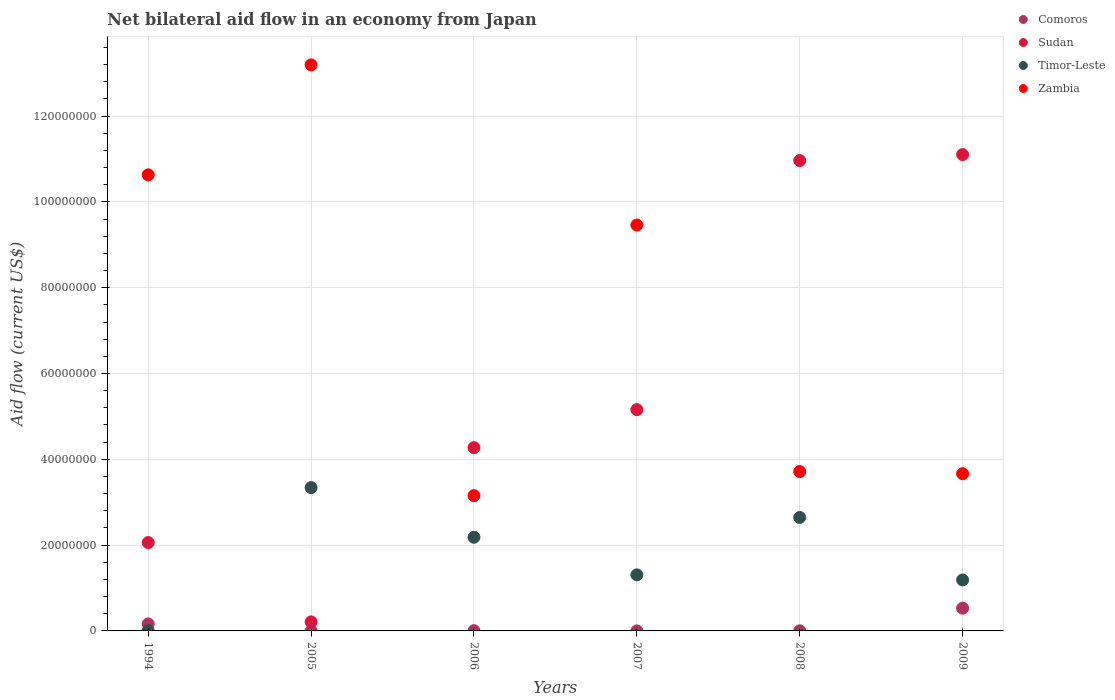How many different coloured dotlines are there?
Provide a short and direct response. 4. What is the net bilateral aid flow in Zambia in 1994?
Offer a terse response. 1.06e+08. Across all years, what is the maximum net bilateral aid flow in Sudan?
Your answer should be very brief. 1.11e+08. Across all years, what is the minimum net bilateral aid flow in Timor-Leste?
Your response must be concise. 7.00e+04. What is the total net bilateral aid flow in Timor-Leste in the graph?
Your answer should be compact. 1.07e+08. What is the difference between the net bilateral aid flow in Zambia in 1994 and that in 2009?
Ensure brevity in your answer.  6.97e+07. What is the difference between the net bilateral aid flow in Zambia in 1994 and the net bilateral aid flow in Comoros in 2005?
Give a very brief answer. 1.06e+08. What is the average net bilateral aid flow in Comoros per year?
Offer a terse response. 1.18e+06. In the year 1994, what is the difference between the net bilateral aid flow in Timor-Leste and net bilateral aid flow in Sudan?
Provide a succinct answer. -2.05e+07. What is the ratio of the net bilateral aid flow in Sudan in 1994 to that in 2006?
Your response must be concise. 0.48. Is the difference between the net bilateral aid flow in Timor-Leste in 2008 and 2009 greater than the difference between the net bilateral aid flow in Sudan in 2008 and 2009?
Your response must be concise. Yes. What is the difference between the highest and the second highest net bilateral aid flow in Zambia?
Give a very brief answer. 2.56e+07. What is the difference between the highest and the lowest net bilateral aid flow in Comoros?
Your answer should be compact. 5.29e+06. In how many years, is the net bilateral aid flow in Comoros greater than the average net bilateral aid flow in Comoros taken over all years?
Offer a very short reply. 2. Is it the case that in every year, the sum of the net bilateral aid flow in Zambia and net bilateral aid flow in Comoros  is greater than the sum of net bilateral aid flow in Sudan and net bilateral aid flow in Timor-Leste?
Make the answer very short. No. Is it the case that in every year, the sum of the net bilateral aid flow in Timor-Leste and net bilateral aid flow in Sudan  is greater than the net bilateral aid flow in Zambia?
Provide a short and direct response. No. Is the net bilateral aid flow in Comoros strictly greater than the net bilateral aid flow in Timor-Leste over the years?
Provide a short and direct response. No. Is the net bilateral aid flow in Timor-Leste strictly less than the net bilateral aid flow in Sudan over the years?
Offer a very short reply. No. How many dotlines are there?
Ensure brevity in your answer.  4. How many years are there in the graph?
Ensure brevity in your answer.  6. What is the difference between two consecutive major ticks on the Y-axis?
Make the answer very short. 2.00e+07. How many legend labels are there?
Your response must be concise. 4. How are the legend labels stacked?
Offer a terse response. Vertical. What is the title of the graph?
Offer a very short reply. Net bilateral aid flow in an economy from Japan. Does "Vietnam" appear as one of the legend labels in the graph?
Keep it short and to the point. No. What is the label or title of the Y-axis?
Provide a short and direct response. Aid flow (current US$). What is the Aid flow (current US$) of Comoros in 1994?
Provide a short and direct response. 1.64e+06. What is the Aid flow (current US$) in Sudan in 1994?
Ensure brevity in your answer.  2.06e+07. What is the Aid flow (current US$) in Timor-Leste in 1994?
Give a very brief answer. 7.00e+04. What is the Aid flow (current US$) in Zambia in 1994?
Provide a short and direct response. 1.06e+08. What is the Aid flow (current US$) in Sudan in 2005?
Offer a terse response. 2.11e+06. What is the Aid flow (current US$) in Timor-Leste in 2005?
Offer a terse response. 3.34e+07. What is the Aid flow (current US$) in Zambia in 2005?
Provide a short and direct response. 1.32e+08. What is the Aid flow (current US$) of Comoros in 2006?
Provide a succinct answer. 6.00e+04. What is the Aid flow (current US$) of Sudan in 2006?
Keep it short and to the point. 4.27e+07. What is the Aid flow (current US$) in Timor-Leste in 2006?
Keep it short and to the point. 2.18e+07. What is the Aid flow (current US$) of Zambia in 2006?
Your answer should be very brief. 3.15e+07. What is the Aid flow (current US$) in Sudan in 2007?
Provide a succinct answer. 5.16e+07. What is the Aid flow (current US$) of Timor-Leste in 2007?
Make the answer very short. 1.31e+07. What is the Aid flow (current US$) in Zambia in 2007?
Your answer should be very brief. 9.46e+07. What is the Aid flow (current US$) in Sudan in 2008?
Ensure brevity in your answer.  1.10e+08. What is the Aid flow (current US$) in Timor-Leste in 2008?
Your response must be concise. 2.64e+07. What is the Aid flow (current US$) of Zambia in 2008?
Your answer should be very brief. 3.71e+07. What is the Aid flow (current US$) of Comoros in 2009?
Your answer should be very brief. 5.30e+06. What is the Aid flow (current US$) of Sudan in 2009?
Keep it short and to the point. 1.11e+08. What is the Aid flow (current US$) in Timor-Leste in 2009?
Your answer should be very brief. 1.19e+07. What is the Aid flow (current US$) of Zambia in 2009?
Ensure brevity in your answer.  3.66e+07. Across all years, what is the maximum Aid flow (current US$) of Comoros?
Provide a short and direct response. 5.30e+06. Across all years, what is the maximum Aid flow (current US$) of Sudan?
Provide a succinct answer. 1.11e+08. Across all years, what is the maximum Aid flow (current US$) of Timor-Leste?
Your response must be concise. 3.34e+07. Across all years, what is the maximum Aid flow (current US$) of Zambia?
Your answer should be compact. 1.32e+08. Across all years, what is the minimum Aid flow (current US$) in Sudan?
Ensure brevity in your answer.  2.11e+06. Across all years, what is the minimum Aid flow (current US$) of Timor-Leste?
Make the answer very short. 7.00e+04. Across all years, what is the minimum Aid flow (current US$) in Zambia?
Give a very brief answer. 3.15e+07. What is the total Aid flow (current US$) of Comoros in the graph?
Provide a short and direct response. 7.07e+06. What is the total Aid flow (current US$) in Sudan in the graph?
Offer a very short reply. 3.38e+08. What is the total Aid flow (current US$) in Timor-Leste in the graph?
Provide a short and direct response. 1.07e+08. What is the total Aid flow (current US$) of Zambia in the graph?
Give a very brief answer. 4.38e+08. What is the difference between the Aid flow (current US$) in Comoros in 1994 and that in 2005?
Offer a very short reply. 1.61e+06. What is the difference between the Aid flow (current US$) of Sudan in 1994 and that in 2005?
Keep it short and to the point. 1.85e+07. What is the difference between the Aid flow (current US$) in Timor-Leste in 1994 and that in 2005?
Provide a succinct answer. -3.33e+07. What is the difference between the Aid flow (current US$) in Zambia in 1994 and that in 2005?
Ensure brevity in your answer.  -2.56e+07. What is the difference between the Aid flow (current US$) in Comoros in 1994 and that in 2006?
Make the answer very short. 1.58e+06. What is the difference between the Aid flow (current US$) of Sudan in 1994 and that in 2006?
Provide a succinct answer. -2.21e+07. What is the difference between the Aid flow (current US$) in Timor-Leste in 1994 and that in 2006?
Offer a terse response. -2.18e+07. What is the difference between the Aid flow (current US$) of Zambia in 1994 and that in 2006?
Your answer should be very brief. 7.48e+07. What is the difference between the Aid flow (current US$) in Comoros in 1994 and that in 2007?
Make the answer very short. 1.63e+06. What is the difference between the Aid flow (current US$) in Sudan in 1994 and that in 2007?
Your answer should be compact. -3.10e+07. What is the difference between the Aid flow (current US$) of Timor-Leste in 1994 and that in 2007?
Provide a succinct answer. -1.30e+07. What is the difference between the Aid flow (current US$) in Zambia in 1994 and that in 2007?
Your response must be concise. 1.17e+07. What is the difference between the Aid flow (current US$) of Comoros in 1994 and that in 2008?
Provide a succinct answer. 1.61e+06. What is the difference between the Aid flow (current US$) in Sudan in 1994 and that in 2008?
Provide a short and direct response. -8.90e+07. What is the difference between the Aid flow (current US$) of Timor-Leste in 1994 and that in 2008?
Offer a terse response. -2.64e+07. What is the difference between the Aid flow (current US$) in Zambia in 1994 and that in 2008?
Your answer should be very brief. 6.92e+07. What is the difference between the Aid flow (current US$) in Comoros in 1994 and that in 2009?
Your response must be concise. -3.66e+06. What is the difference between the Aid flow (current US$) in Sudan in 1994 and that in 2009?
Provide a succinct answer. -9.04e+07. What is the difference between the Aid flow (current US$) of Timor-Leste in 1994 and that in 2009?
Keep it short and to the point. -1.18e+07. What is the difference between the Aid flow (current US$) in Zambia in 1994 and that in 2009?
Provide a succinct answer. 6.97e+07. What is the difference between the Aid flow (current US$) of Sudan in 2005 and that in 2006?
Ensure brevity in your answer.  -4.06e+07. What is the difference between the Aid flow (current US$) in Timor-Leste in 2005 and that in 2006?
Make the answer very short. 1.16e+07. What is the difference between the Aid flow (current US$) of Zambia in 2005 and that in 2006?
Keep it short and to the point. 1.00e+08. What is the difference between the Aid flow (current US$) in Comoros in 2005 and that in 2007?
Give a very brief answer. 2.00e+04. What is the difference between the Aid flow (current US$) in Sudan in 2005 and that in 2007?
Provide a succinct answer. -4.95e+07. What is the difference between the Aid flow (current US$) of Timor-Leste in 2005 and that in 2007?
Ensure brevity in your answer.  2.03e+07. What is the difference between the Aid flow (current US$) in Zambia in 2005 and that in 2007?
Keep it short and to the point. 3.73e+07. What is the difference between the Aid flow (current US$) in Comoros in 2005 and that in 2008?
Offer a very short reply. 0. What is the difference between the Aid flow (current US$) in Sudan in 2005 and that in 2008?
Your response must be concise. -1.08e+08. What is the difference between the Aid flow (current US$) in Timor-Leste in 2005 and that in 2008?
Offer a terse response. 6.96e+06. What is the difference between the Aid flow (current US$) in Zambia in 2005 and that in 2008?
Offer a terse response. 9.48e+07. What is the difference between the Aid flow (current US$) in Comoros in 2005 and that in 2009?
Provide a short and direct response. -5.27e+06. What is the difference between the Aid flow (current US$) in Sudan in 2005 and that in 2009?
Your response must be concise. -1.09e+08. What is the difference between the Aid flow (current US$) in Timor-Leste in 2005 and that in 2009?
Provide a succinct answer. 2.15e+07. What is the difference between the Aid flow (current US$) of Zambia in 2005 and that in 2009?
Make the answer very short. 9.53e+07. What is the difference between the Aid flow (current US$) of Sudan in 2006 and that in 2007?
Provide a short and direct response. -8.86e+06. What is the difference between the Aid flow (current US$) in Timor-Leste in 2006 and that in 2007?
Make the answer very short. 8.76e+06. What is the difference between the Aid flow (current US$) of Zambia in 2006 and that in 2007?
Keep it short and to the point. -6.31e+07. What is the difference between the Aid flow (current US$) in Sudan in 2006 and that in 2008?
Provide a short and direct response. -6.69e+07. What is the difference between the Aid flow (current US$) of Timor-Leste in 2006 and that in 2008?
Offer a terse response. -4.62e+06. What is the difference between the Aid flow (current US$) of Zambia in 2006 and that in 2008?
Your answer should be compact. -5.61e+06. What is the difference between the Aid flow (current US$) in Comoros in 2006 and that in 2009?
Ensure brevity in your answer.  -5.24e+06. What is the difference between the Aid flow (current US$) of Sudan in 2006 and that in 2009?
Offer a terse response. -6.83e+07. What is the difference between the Aid flow (current US$) in Timor-Leste in 2006 and that in 2009?
Your answer should be very brief. 9.95e+06. What is the difference between the Aid flow (current US$) in Zambia in 2006 and that in 2009?
Your answer should be very brief. -5.11e+06. What is the difference between the Aid flow (current US$) of Comoros in 2007 and that in 2008?
Offer a terse response. -2.00e+04. What is the difference between the Aid flow (current US$) in Sudan in 2007 and that in 2008?
Provide a succinct answer. -5.81e+07. What is the difference between the Aid flow (current US$) of Timor-Leste in 2007 and that in 2008?
Your answer should be compact. -1.34e+07. What is the difference between the Aid flow (current US$) of Zambia in 2007 and that in 2008?
Offer a terse response. 5.75e+07. What is the difference between the Aid flow (current US$) in Comoros in 2007 and that in 2009?
Your answer should be very brief. -5.29e+06. What is the difference between the Aid flow (current US$) of Sudan in 2007 and that in 2009?
Your response must be concise. -5.94e+07. What is the difference between the Aid flow (current US$) in Timor-Leste in 2007 and that in 2009?
Give a very brief answer. 1.19e+06. What is the difference between the Aid flow (current US$) in Zambia in 2007 and that in 2009?
Make the answer very short. 5.80e+07. What is the difference between the Aid flow (current US$) of Comoros in 2008 and that in 2009?
Make the answer very short. -5.27e+06. What is the difference between the Aid flow (current US$) in Sudan in 2008 and that in 2009?
Your answer should be compact. -1.39e+06. What is the difference between the Aid flow (current US$) of Timor-Leste in 2008 and that in 2009?
Offer a very short reply. 1.46e+07. What is the difference between the Aid flow (current US$) in Zambia in 2008 and that in 2009?
Provide a succinct answer. 5.00e+05. What is the difference between the Aid flow (current US$) in Comoros in 1994 and the Aid flow (current US$) in Sudan in 2005?
Your answer should be very brief. -4.70e+05. What is the difference between the Aid flow (current US$) of Comoros in 1994 and the Aid flow (current US$) of Timor-Leste in 2005?
Provide a succinct answer. -3.18e+07. What is the difference between the Aid flow (current US$) of Comoros in 1994 and the Aid flow (current US$) of Zambia in 2005?
Your answer should be very brief. -1.30e+08. What is the difference between the Aid flow (current US$) of Sudan in 1994 and the Aid flow (current US$) of Timor-Leste in 2005?
Keep it short and to the point. -1.28e+07. What is the difference between the Aid flow (current US$) in Sudan in 1994 and the Aid flow (current US$) in Zambia in 2005?
Keep it short and to the point. -1.11e+08. What is the difference between the Aid flow (current US$) of Timor-Leste in 1994 and the Aid flow (current US$) of Zambia in 2005?
Keep it short and to the point. -1.32e+08. What is the difference between the Aid flow (current US$) of Comoros in 1994 and the Aid flow (current US$) of Sudan in 2006?
Your answer should be very brief. -4.11e+07. What is the difference between the Aid flow (current US$) of Comoros in 1994 and the Aid flow (current US$) of Timor-Leste in 2006?
Provide a succinct answer. -2.02e+07. What is the difference between the Aid flow (current US$) of Comoros in 1994 and the Aid flow (current US$) of Zambia in 2006?
Offer a terse response. -2.99e+07. What is the difference between the Aid flow (current US$) in Sudan in 1994 and the Aid flow (current US$) in Timor-Leste in 2006?
Offer a terse response. -1.23e+06. What is the difference between the Aid flow (current US$) in Sudan in 1994 and the Aid flow (current US$) in Zambia in 2006?
Offer a terse response. -1.09e+07. What is the difference between the Aid flow (current US$) in Timor-Leste in 1994 and the Aid flow (current US$) in Zambia in 2006?
Keep it short and to the point. -3.15e+07. What is the difference between the Aid flow (current US$) in Comoros in 1994 and the Aid flow (current US$) in Sudan in 2007?
Offer a terse response. -4.99e+07. What is the difference between the Aid flow (current US$) of Comoros in 1994 and the Aid flow (current US$) of Timor-Leste in 2007?
Your answer should be very brief. -1.14e+07. What is the difference between the Aid flow (current US$) in Comoros in 1994 and the Aid flow (current US$) in Zambia in 2007?
Your response must be concise. -9.30e+07. What is the difference between the Aid flow (current US$) in Sudan in 1994 and the Aid flow (current US$) in Timor-Leste in 2007?
Your response must be concise. 7.53e+06. What is the difference between the Aid flow (current US$) of Sudan in 1994 and the Aid flow (current US$) of Zambia in 2007?
Provide a short and direct response. -7.40e+07. What is the difference between the Aid flow (current US$) in Timor-Leste in 1994 and the Aid flow (current US$) in Zambia in 2007?
Ensure brevity in your answer.  -9.45e+07. What is the difference between the Aid flow (current US$) of Comoros in 1994 and the Aid flow (current US$) of Sudan in 2008?
Keep it short and to the point. -1.08e+08. What is the difference between the Aid flow (current US$) in Comoros in 1994 and the Aid flow (current US$) in Timor-Leste in 2008?
Your answer should be very brief. -2.48e+07. What is the difference between the Aid flow (current US$) of Comoros in 1994 and the Aid flow (current US$) of Zambia in 2008?
Provide a succinct answer. -3.55e+07. What is the difference between the Aid flow (current US$) in Sudan in 1994 and the Aid flow (current US$) in Timor-Leste in 2008?
Offer a terse response. -5.85e+06. What is the difference between the Aid flow (current US$) of Sudan in 1994 and the Aid flow (current US$) of Zambia in 2008?
Offer a terse response. -1.65e+07. What is the difference between the Aid flow (current US$) in Timor-Leste in 1994 and the Aid flow (current US$) in Zambia in 2008?
Provide a succinct answer. -3.71e+07. What is the difference between the Aid flow (current US$) of Comoros in 1994 and the Aid flow (current US$) of Sudan in 2009?
Keep it short and to the point. -1.09e+08. What is the difference between the Aid flow (current US$) of Comoros in 1994 and the Aid flow (current US$) of Timor-Leste in 2009?
Make the answer very short. -1.02e+07. What is the difference between the Aid flow (current US$) in Comoros in 1994 and the Aid flow (current US$) in Zambia in 2009?
Your response must be concise. -3.50e+07. What is the difference between the Aid flow (current US$) of Sudan in 1994 and the Aid flow (current US$) of Timor-Leste in 2009?
Make the answer very short. 8.72e+06. What is the difference between the Aid flow (current US$) of Sudan in 1994 and the Aid flow (current US$) of Zambia in 2009?
Your response must be concise. -1.60e+07. What is the difference between the Aid flow (current US$) of Timor-Leste in 1994 and the Aid flow (current US$) of Zambia in 2009?
Give a very brief answer. -3.66e+07. What is the difference between the Aid flow (current US$) of Comoros in 2005 and the Aid flow (current US$) of Sudan in 2006?
Ensure brevity in your answer.  -4.27e+07. What is the difference between the Aid flow (current US$) in Comoros in 2005 and the Aid flow (current US$) in Timor-Leste in 2006?
Your answer should be compact. -2.18e+07. What is the difference between the Aid flow (current US$) in Comoros in 2005 and the Aid flow (current US$) in Zambia in 2006?
Make the answer very short. -3.15e+07. What is the difference between the Aid flow (current US$) in Sudan in 2005 and the Aid flow (current US$) in Timor-Leste in 2006?
Offer a very short reply. -1.97e+07. What is the difference between the Aid flow (current US$) of Sudan in 2005 and the Aid flow (current US$) of Zambia in 2006?
Offer a very short reply. -2.94e+07. What is the difference between the Aid flow (current US$) of Timor-Leste in 2005 and the Aid flow (current US$) of Zambia in 2006?
Offer a very short reply. 1.88e+06. What is the difference between the Aid flow (current US$) in Comoros in 2005 and the Aid flow (current US$) in Sudan in 2007?
Offer a terse response. -5.16e+07. What is the difference between the Aid flow (current US$) in Comoros in 2005 and the Aid flow (current US$) in Timor-Leste in 2007?
Your response must be concise. -1.30e+07. What is the difference between the Aid flow (current US$) of Comoros in 2005 and the Aid flow (current US$) of Zambia in 2007?
Keep it short and to the point. -9.46e+07. What is the difference between the Aid flow (current US$) in Sudan in 2005 and the Aid flow (current US$) in Timor-Leste in 2007?
Provide a succinct answer. -1.10e+07. What is the difference between the Aid flow (current US$) in Sudan in 2005 and the Aid flow (current US$) in Zambia in 2007?
Your response must be concise. -9.25e+07. What is the difference between the Aid flow (current US$) in Timor-Leste in 2005 and the Aid flow (current US$) in Zambia in 2007?
Your answer should be very brief. -6.12e+07. What is the difference between the Aid flow (current US$) of Comoros in 2005 and the Aid flow (current US$) of Sudan in 2008?
Your response must be concise. -1.10e+08. What is the difference between the Aid flow (current US$) in Comoros in 2005 and the Aid flow (current US$) in Timor-Leste in 2008?
Give a very brief answer. -2.64e+07. What is the difference between the Aid flow (current US$) of Comoros in 2005 and the Aid flow (current US$) of Zambia in 2008?
Offer a terse response. -3.71e+07. What is the difference between the Aid flow (current US$) in Sudan in 2005 and the Aid flow (current US$) in Timor-Leste in 2008?
Make the answer very short. -2.43e+07. What is the difference between the Aid flow (current US$) in Sudan in 2005 and the Aid flow (current US$) in Zambia in 2008?
Give a very brief answer. -3.50e+07. What is the difference between the Aid flow (current US$) in Timor-Leste in 2005 and the Aid flow (current US$) in Zambia in 2008?
Your answer should be compact. -3.73e+06. What is the difference between the Aid flow (current US$) of Comoros in 2005 and the Aid flow (current US$) of Sudan in 2009?
Give a very brief answer. -1.11e+08. What is the difference between the Aid flow (current US$) in Comoros in 2005 and the Aid flow (current US$) in Timor-Leste in 2009?
Your answer should be compact. -1.18e+07. What is the difference between the Aid flow (current US$) of Comoros in 2005 and the Aid flow (current US$) of Zambia in 2009?
Give a very brief answer. -3.66e+07. What is the difference between the Aid flow (current US$) in Sudan in 2005 and the Aid flow (current US$) in Timor-Leste in 2009?
Keep it short and to the point. -9.77e+06. What is the difference between the Aid flow (current US$) of Sudan in 2005 and the Aid flow (current US$) of Zambia in 2009?
Offer a terse response. -3.45e+07. What is the difference between the Aid flow (current US$) of Timor-Leste in 2005 and the Aid flow (current US$) of Zambia in 2009?
Provide a short and direct response. -3.23e+06. What is the difference between the Aid flow (current US$) in Comoros in 2006 and the Aid flow (current US$) in Sudan in 2007?
Your answer should be very brief. -5.15e+07. What is the difference between the Aid flow (current US$) of Comoros in 2006 and the Aid flow (current US$) of Timor-Leste in 2007?
Keep it short and to the point. -1.30e+07. What is the difference between the Aid flow (current US$) in Comoros in 2006 and the Aid flow (current US$) in Zambia in 2007?
Your answer should be very brief. -9.46e+07. What is the difference between the Aid flow (current US$) of Sudan in 2006 and the Aid flow (current US$) of Timor-Leste in 2007?
Your answer should be compact. 2.96e+07. What is the difference between the Aid flow (current US$) in Sudan in 2006 and the Aid flow (current US$) in Zambia in 2007?
Your answer should be very brief. -5.19e+07. What is the difference between the Aid flow (current US$) of Timor-Leste in 2006 and the Aid flow (current US$) of Zambia in 2007?
Offer a very short reply. -7.28e+07. What is the difference between the Aid flow (current US$) in Comoros in 2006 and the Aid flow (current US$) in Sudan in 2008?
Your answer should be very brief. -1.10e+08. What is the difference between the Aid flow (current US$) of Comoros in 2006 and the Aid flow (current US$) of Timor-Leste in 2008?
Ensure brevity in your answer.  -2.64e+07. What is the difference between the Aid flow (current US$) in Comoros in 2006 and the Aid flow (current US$) in Zambia in 2008?
Offer a terse response. -3.71e+07. What is the difference between the Aid flow (current US$) of Sudan in 2006 and the Aid flow (current US$) of Timor-Leste in 2008?
Your answer should be very brief. 1.63e+07. What is the difference between the Aid flow (current US$) in Sudan in 2006 and the Aid flow (current US$) in Zambia in 2008?
Make the answer very short. 5.58e+06. What is the difference between the Aid flow (current US$) in Timor-Leste in 2006 and the Aid flow (current US$) in Zambia in 2008?
Your response must be concise. -1.53e+07. What is the difference between the Aid flow (current US$) of Comoros in 2006 and the Aid flow (current US$) of Sudan in 2009?
Provide a succinct answer. -1.11e+08. What is the difference between the Aid flow (current US$) of Comoros in 2006 and the Aid flow (current US$) of Timor-Leste in 2009?
Your response must be concise. -1.18e+07. What is the difference between the Aid flow (current US$) of Comoros in 2006 and the Aid flow (current US$) of Zambia in 2009?
Your answer should be very brief. -3.66e+07. What is the difference between the Aid flow (current US$) of Sudan in 2006 and the Aid flow (current US$) of Timor-Leste in 2009?
Keep it short and to the point. 3.08e+07. What is the difference between the Aid flow (current US$) of Sudan in 2006 and the Aid flow (current US$) of Zambia in 2009?
Offer a terse response. 6.08e+06. What is the difference between the Aid flow (current US$) in Timor-Leste in 2006 and the Aid flow (current US$) in Zambia in 2009?
Give a very brief answer. -1.48e+07. What is the difference between the Aid flow (current US$) of Comoros in 2007 and the Aid flow (current US$) of Sudan in 2008?
Make the answer very short. -1.10e+08. What is the difference between the Aid flow (current US$) of Comoros in 2007 and the Aid flow (current US$) of Timor-Leste in 2008?
Offer a very short reply. -2.64e+07. What is the difference between the Aid flow (current US$) of Comoros in 2007 and the Aid flow (current US$) of Zambia in 2008?
Your answer should be compact. -3.71e+07. What is the difference between the Aid flow (current US$) of Sudan in 2007 and the Aid flow (current US$) of Timor-Leste in 2008?
Your response must be concise. 2.51e+07. What is the difference between the Aid flow (current US$) of Sudan in 2007 and the Aid flow (current US$) of Zambia in 2008?
Give a very brief answer. 1.44e+07. What is the difference between the Aid flow (current US$) in Timor-Leste in 2007 and the Aid flow (current US$) in Zambia in 2008?
Offer a terse response. -2.41e+07. What is the difference between the Aid flow (current US$) of Comoros in 2007 and the Aid flow (current US$) of Sudan in 2009?
Offer a very short reply. -1.11e+08. What is the difference between the Aid flow (current US$) of Comoros in 2007 and the Aid flow (current US$) of Timor-Leste in 2009?
Keep it short and to the point. -1.19e+07. What is the difference between the Aid flow (current US$) of Comoros in 2007 and the Aid flow (current US$) of Zambia in 2009?
Give a very brief answer. -3.66e+07. What is the difference between the Aid flow (current US$) in Sudan in 2007 and the Aid flow (current US$) in Timor-Leste in 2009?
Your answer should be very brief. 3.97e+07. What is the difference between the Aid flow (current US$) of Sudan in 2007 and the Aid flow (current US$) of Zambia in 2009?
Your response must be concise. 1.49e+07. What is the difference between the Aid flow (current US$) in Timor-Leste in 2007 and the Aid flow (current US$) in Zambia in 2009?
Your response must be concise. -2.36e+07. What is the difference between the Aid flow (current US$) in Comoros in 2008 and the Aid flow (current US$) in Sudan in 2009?
Offer a very short reply. -1.11e+08. What is the difference between the Aid flow (current US$) of Comoros in 2008 and the Aid flow (current US$) of Timor-Leste in 2009?
Your answer should be compact. -1.18e+07. What is the difference between the Aid flow (current US$) in Comoros in 2008 and the Aid flow (current US$) in Zambia in 2009?
Make the answer very short. -3.66e+07. What is the difference between the Aid flow (current US$) in Sudan in 2008 and the Aid flow (current US$) in Timor-Leste in 2009?
Provide a succinct answer. 9.78e+07. What is the difference between the Aid flow (current US$) in Sudan in 2008 and the Aid flow (current US$) in Zambia in 2009?
Make the answer very short. 7.30e+07. What is the difference between the Aid flow (current US$) of Timor-Leste in 2008 and the Aid flow (current US$) of Zambia in 2009?
Your answer should be compact. -1.02e+07. What is the average Aid flow (current US$) of Comoros per year?
Your answer should be very brief. 1.18e+06. What is the average Aid flow (current US$) of Sudan per year?
Give a very brief answer. 5.63e+07. What is the average Aid flow (current US$) in Timor-Leste per year?
Provide a succinct answer. 1.78e+07. What is the average Aid flow (current US$) in Zambia per year?
Ensure brevity in your answer.  7.30e+07. In the year 1994, what is the difference between the Aid flow (current US$) of Comoros and Aid flow (current US$) of Sudan?
Offer a terse response. -1.90e+07. In the year 1994, what is the difference between the Aid flow (current US$) of Comoros and Aid flow (current US$) of Timor-Leste?
Your response must be concise. 1.57e+06. In the year 1994, what is the difference between the Aid flow (current US$) of Comoros and Aid flow (current US$) of Zambia?
Provide a short and direct response. -1.05e+08. In the year 1994, what is the difference between the Aid flow (current US$) of Sudan and Aid flow (current US$) of Timor-Leste?
Provide a short and direct response. 2.05e+07. In the year 1994, what is the difference between the Aid flow (current US$) in Sudan and Aid flow (current US$) in Zambia?
Offer a terse response. -8.57e+07. In the year 1994, what is the difference between the Aid flow (current US$) of Timor-Leste and Aid flow (current US$) of Zambia?
Your answer should be very brief. -1.06e+08. In the year 2005, what is the difference between the Aid flow (current US$) of Comoros and Aid flow (current US$) of Sudan?
Your answer should be very brief. -2.08e+06. In the year 2005, what is the difference between the Aid flow (current US$) in Comoros and Aid flow (current US$) in Timor-Leste?
Make the answer very short. -3.34e+07. In the year 2005, what is the difference between the Aid flow (current US$) in Comoros and Aid flow (current US$) in Zambia?
Offer a very short reply. -1.32e+08. In the year 2005, what is the difference between the Aid flow (current US$) in Sudan and Aid flow (current US$) in Timor-Leste?
Your response must be concise. -3.13e+07. In the year 2005, what is the difference between the Aid flow (current US$) in Sudan and Aid flow (current US$) in Zambia?
Provide a succinct answer. -1.30e+08. In the year 2005, what is the difference between the Aid flow (current US$) of Timor-Leste and Aid flow (current US$) of Zambia?
Give a very brief answer. -9.85e+07. In the year 2006, what is the difference between the Aid flow (current US$) in Comoros and Aid flow (current US$) in Sudan?
Provide a succinct answer. -4.27e+07. In the year 2006, what is the difference between the Aid flow (current US$) of Comoros and Aid flow (current US$) of Timor-Leste?
Your answer should be compact. -2.18e+07. In the year 2006, what is the difference between the Aid flow (current US$) of Comoros and Aid flow (current US$) of Zambia?
Your response must be concise. -3.15e+07. In the year 2006, what is the difference between the Aid flow (current US$) of Sudan and Aid flow (current US$) of Timor-Leste?
Make the answer very short. 2.09e+07. In the year 2006, what is the difference between the Aid flow (current US$) of Sudan and Aid flow (current US$) of Zambia?
Make the answer very short. 1.12e+07. In the year 2006, what is the difference between the Aid flow (current US$) of Timor-Leste and Aid flow (current US$) of Zambia?
Offer a very short reply. -9.70e+06. In the year 2007, what is the difference between the Aid flow (current US$) in Comoros and Aid flow (current US$) in Sudan?
Ensure brevity in your answer.  -5.16e+07. In the year 2007, what is the difference between the Aid flow (current US$) in Comoros and Aid flow (current US$) in Timor-Leste?
Make the answer very short. -1.31e+07. In the year 2007, what is the difference between the Aid flow (current US$) in Comoros and Aid flow (current US$) in Zambia?
Make the answer very short. -9.46e+07. In the year 2007, what is the difference between the Aid flow (current US$) of Sudan and Aid flow (current US$) of Timor-Leste?
Your response must be concise. 3.85e+07. In the year 2007, what is the difference between the Aid flow (current US$) of Sudan and Aid flow (current US$) of Zambia?
Give a very brief answer. -4.30e+07. In the year 2007, what is the difference between the Aid flow (current US$) in Timor-Leste and Aid flow (current US$) in Zambia?
Provide a short and direct response. -8.15e+07. In the year 2008, what is the difference between the Aid flow (current US$) in Comoros and Aid flow (current US$) in Sudan?
Your answer should be very brief. -1.10e+08. In the year 2008, what is the difference between the Aid flow (current US$) of Comoros and Aid flow (current US$) of Timor-Leste?
Offer a very short reply. -2.64e+07. In the year 2008, what is the difference between the Aid flow (current US$) of Comoros and Aid flow (current US$) of Zambia?
Provide a short and direct response. -3.71e+07. In the year 2008, what is the difference between the Aid flow (current US$) in Sudan and Aid flow (current US$) in Timor-Leste?
Your answer should be compact. 8.32e+07. In the year 2008, what is the difference between the Aid flow (current US$) of Sudan and Aid flow (current US$) of Zambia?
Your answer should be very brief. 7.25e+07. In the year 2008, what is the difference between the Aid flow (current US$) of Timor-Leste and Aid flow (current US$) of Zambia?
Give a very brief answer. -1.07e+07. In the year 2009, what is the difference between the Aid flow (current US$) of Comoros and Aid flow (current US$) of Sudan?
Give a very brief answer. -1.06e+08. In the year 2009, what is the difference between the Aid flow (current US$) of Comoros and Aid flow (current US$) of Timor-Leste?
Offer a terse response. -6.58e+06. In the year 2009, what is the difference between the Aid flow (current US$) of Comoros and Aid flow (current US$) of Zambia?
Provide a succinct answer. -3.13e+07. In the year 2009, what is the difference between the Aid flow (current US$) of Sudan and Aid flow (current US$) of Timor-Leste?
Offer a very short reply. 9.92e+07. In the year 2009, what is the difference between the Aid flow (current US$) in Sudan and Aid flow (current US$) in Zambia?
Your response must be concise. 7.44e+07. In the year 2009, what is the difference between the Aid flow (current US$) of Timor-Leste and Aid flow (current US$) of Zambia?
Provide a short and direct response. -2.48e+07. What is the ratio of the Aid flow (current US$) in Comoros in 1994 to that in 2005?
Offer a terse response. 54.67. What is the ratio of the Aid flow (current US$) in Sudan in 1994 to that in 2005?
Provide a short and direct response. 9.76. What is the ratio of the Aid flow (current US$) in Timor-Leste in 1994 to that in 2005?
Ensure brevity in your answer.  0. What is the ratio of the Aid flow (current US$) of Zambia in 1994 to that in 2005?
Provide a succinct answer. 0.81. What is the ratio of the Aid flow (current US$) in Comoros in 1994 to that in 2006?
Offer a terse response. 27.33. What is the ratio of the Aid flow (current US$) in Sudan in 1994 to that in 2006?
Provide a short and direct response. 0.48. What is the ratio of the Aid flow (current US$) of Timor-Leste in 1994 to that in 2006?
Keep it short and to the point. 0. What is the ratio of the Aid flow (current US$) in Zambia in 1994 to that in 2006?
Offer a very short reply. 3.37. What is the ratio of the Aid flow (current US$) in Comoros in 1994 to that in 2007?
Make the answer very short. 164. What is the ratio of the Aid flow (current US$) of Sudan in 1994 to that in 2007?
Provide a short and direct response. 0.4. What is the ratio of the Aid flow (current US$) of Timor-Leste in 1994 to that in 2007?
Your answer should be compact. 0.01. What is the ratio of the Aid flow (current US$) of Zambia in 1994 to that in 2007?
Ensure brevity in your answer.  1.12. What is the ratio of the Aid flow (current US$) in Comoros in 1994 to that in 2008?
Provide a succinct answer. 54.67. What is the ratio of the Aid flow (current US$) in Sudan in 1994 to that in 2008?
Provide a succinct answer. 0.19. What is the ratio of the Aid flow (current US$) of Timor-Leste in 1994 to that in 2008?
Provide a short and direct response. 0. What is the ratio of the Aid flow (current US$) of Zambia in 1994 to that in 2008?
Ensure brevity in your answer.  2.86. What is the ratio of the Aid flow (current US$) in Comoros in 1994 to that in 2009?
Provide a short and direct response. 0.31. What is the ratio of the Aid flow (current US$) in Sudan in 1994 to that in 2009?
Your response must be concise. 0.19. What is the ratio of the Aid flow (current US$) of Timor-Leste in 1994 to that in 2009?
Ensure brevity in your answer.  0.01. What is the ratio of the Aid flow (current US$) of Zambia in 1994 to that in 2009?
Your response must be concise. 2.9. What is the ratio of the Aid flow (current US$) in Sudan in 2005 to that in 2006?
Keep it short and to the point. 0.05. What is the ratio of the Aid flow (current US$) in Timor-Leste in 2005 to that in 2006?
Ensure brevity in your answer.  1.53. What is the ratio of the Aid flow (current US$) in Zambia in 2005 to that in 2006?
Give a very brief answer. 4.18. What is the ratio of the Aid flow (current US$) in Comoros in 2005 to that in 2007?
Your response must be concise. 3. What is the ratio of the Aid flow (current US$) of Sudan in 2005 to that in 2007?
Provide a short and direct response. 0.04. What is the ratio of the Aid flow (current US$) of Timor-Leste in 2005 to that in 2007?
Make the answer very short. 2.56. What is the ratio of the Aid flow (current US$) of Zambia in 2005 to that in 2007?
Your answer should be compact. 1.39. What is the ratio of the Aid flow (current US$) of Sudan in 2005 to that in 2008?
Your answer should be very brief. 0.02. What is the ratio of the Aid flow (current US$) in Timor-Leste in 2005 to that in 2008?
Make the answer very short. 1.26. What is the ratio of the Aid flow (current US$) of Zambia in 2005 to that in 2008?
Offer a terse response. 3.55. What is the ratio of the Aid flow (current US$) in Comoros in 2005 to that in 2009?
Provide a short and direct response. 0.01. What is the ratio of the Aid flow (current US$) of Sudan in 2005 to that in 2009?
Offer a terse response. 0.02. What is the ratio of the Aid flow (current US$) of Timor-Leste in 2005 to that in 2009?
Offer a very short reply. 2.81. What is the ratio of the Aid flow (current US$) in Zambia in 2005 to that in 2009?
Offer a very short reply. 3.6. What is the ratio of the Aid flow (current US$) of Comoros in 2006 to that in 2007?
Provide a short and direct response. 6. What is the ratio of the Aid flow (current US$) in Sudan in 2006 to that in 2007?
Your response must be concise. 0.83. What is the ratio of the Aid flow (current US$) in Timor-Leste in 2006 to that in 2007?
Ensure brevity in your answer.  1.67. What is the ratio of the Aid flow (current US$) in Zambia in 2006 to that in 2007?
Offer a very short reply. 0.33. What is the ratio of the Aid flow (current US$) in Sudan in 2006 to that in 2008?
Your answer should be very brief. 0.39. What is the ratio of the Aid flow (current US$) of Timor-Leste in 2006 to that in 2008?
Your answer should be very brief. 0.83. What is the ratio of the Aid flow (current US$) in Zambia in 2006 to that in 2008?
Give a very brief answer. 0.85. What is the ratio of the Aid flow (current US$) of Comoros in 2006 to that in 2009?
Offer a very short reply. 0.01. What is the ratio of the Aid flow (current US$) of Sudan in 2006 to that in 2009?
Ensure brevity in your answer.  0.38. What is the ratio of the Aid flow (current US$) in Timor-Leste in 2006 to that in 2009?
Make the answer very short. 1.84. What is the ratio of the Aid flow (current US$) in Zambia in 2006 to that in 2009?
Your answer should be very brief. 0.86. What is the ratio of the Aid flow (current US$) of Comoros in 2007 to that in 2008?
Your answer should be compact. 0.33. What is the ratio of the Aid flow (current US$) of Sudan in 2007 to that in 2008?
Offer a terse response. 0.47. What is the ratio of the Aid flow (current US$) in Timor-Leste in 2007 to that in 2008?
Ensure brevity in your answer.  0.49. What is the ratio of the Aid flow (current US$) of Zambia in 2007 to that in 2008?
Offer a very short reply. 2.55. What is the ratio of the Aid flow (current US$) in Comoros in 2007 to that in 2009?
Your answer should be very brief. 0. What is the ratio of the Aid flow (current US$) in Sudan in 2007 to that in 2009?
Provide a short and direct response. 0.46. What is the ratio of the Aid flow (current US$) in Timor-Leste in 2007 to that in 2009?
Provide a succinct answer. 1.1. What is the ratio of the Aid flow (current US$) in Zambia in 2007 to that in 2009?
Make the answer very short. 2.58. What is the ratio of the Aid flow (current US$) in Comoros in 2008 to that in 2009?
Your response must be concise. 0.01. What is the ratio of the Aid flow (current US$) of Sudan in 2008 to that in 2009?
Keep it short and to the point. 0.99. What is the ratio of the Aid flow (current US$) of Timor-Leste in 2008 to that in 2009?
Your answer should be very brief. 2.23. What is the ratio of the Aid flow (current US$) in Zambia in 2008 to that in 2009?
Ensure brevity in your answer.  1.01. What is the difference between the highest and the second highest Aid flow (current US$) of Comoros?
Offer a very short reply. 3.66e+06. What is the difference between the highest and the second highest Aid flow (current US$) in Sudan?
Provide a succinct answer. 1.39e+06. What is the difference between the highest and the second highest Aid flow (current US$) in Timor-Leste?
Your answer should be compact. 6.96e+06. What is the difference between the highest and the second highest Aid flow (current US$) of Zambia?
Make the answer very short. 2.56e+07. What is the difference between the highest and the lowest Aid flow (current US$) in Comoros?
Keep it short and to the point. 5.29e+06. What is the difference between the highest and the lowest Aid flow (current US$) of Sudan?
Provide a short and direct response. 1.09e+08. What is the difference between the highest and the lowest Aid flow (current US$) in Timor-Leste?
Provide a short and direct response. 3.33e+07. What is the difference between the highest and the lowest Aid flow (current US$) of Zambia?
Make the answer very short. 1.00e+08. 